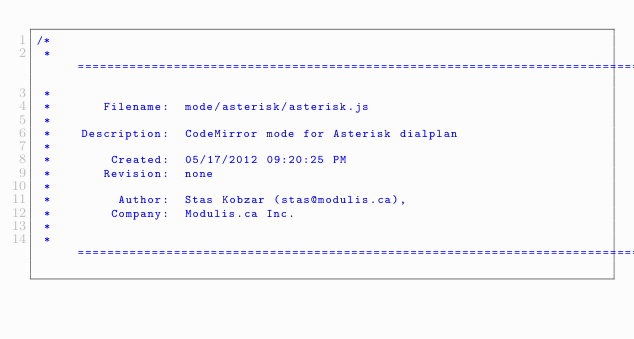Convert code to text. <code><loc_0><loc_0><loc_500><loc_500><_JavaScript_>/*
 * =====================================================================================
 *
 *       Filename:  mode/asterisk/asterisk.js
 *
 *    Description:  CodeMirror mode for Asterisk dialplan
 *
 *        Created:  05/17/2012 09:20:25 PM
 *       Revision:  none
 *
 *         Author:  Stas Kobzar (stas@modulis.ca),
 *        Company:  Modulis.ca Inc.
 *
 * =====================================================================================</code> 